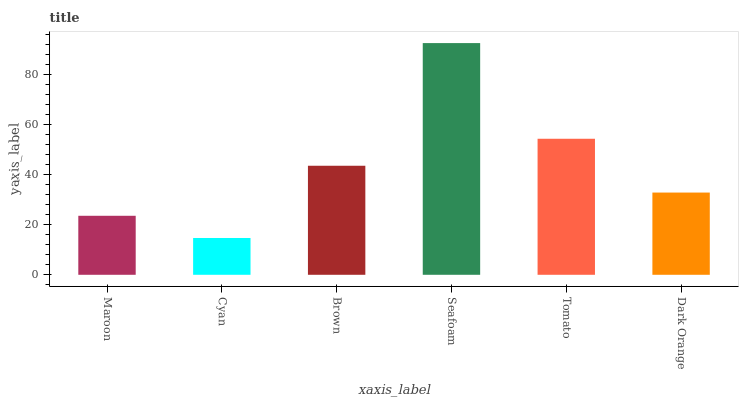Is Cyan the minimum?
Answer yes or no. Yes. Is Seafoam the maximum?
Answer yes or no. Yes. Is Brown the minimum?
Answer yes or no. No. Is Brown the maximum?
Answer yes or no. No. Is Brown greater than Cyan?
Answer yes or no. Yes. Is Cyan less than Brown?
Answer yes or no. Yes. Is Cyan greater than Brown?
Answer yes or no. No. Is Brown less than Cyan?
Answer yes or no. No. Is Brown the high median?
Answer yes or no. Yes. Is Dark Orange the low median?
Answer yes or no. Yes. Is Cyan the high median?
Answer yes or no. No. Is Tomato the low median?
Answer yes or no. No. 